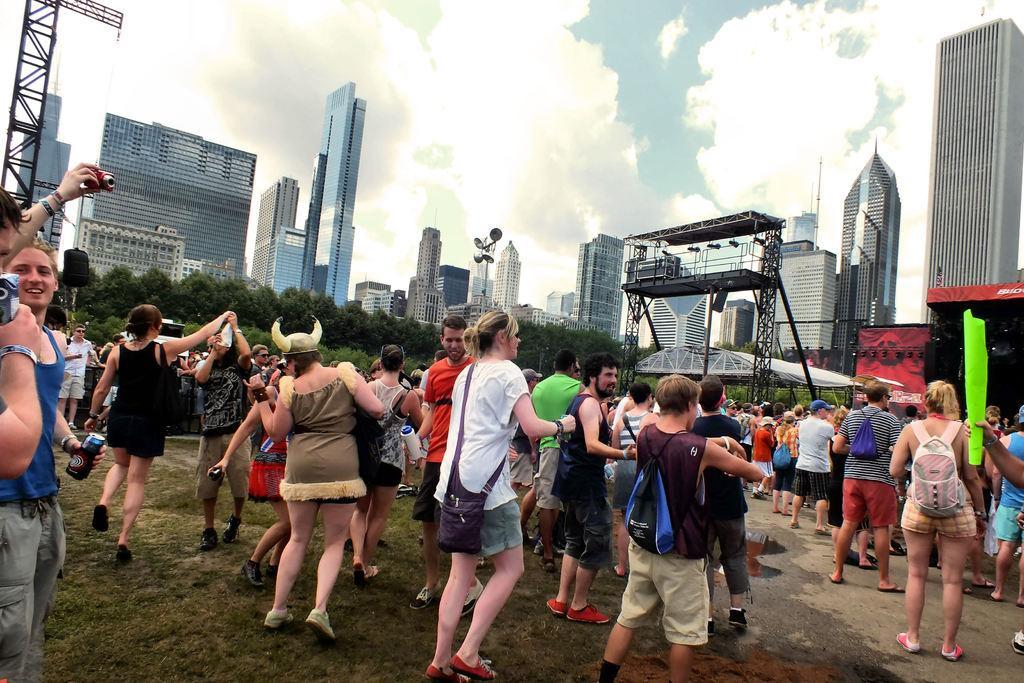How would you summarize this image in a sentence or two? In this image there are people standing, in the background there are speakers, lights, buildings, trees and the sky. 